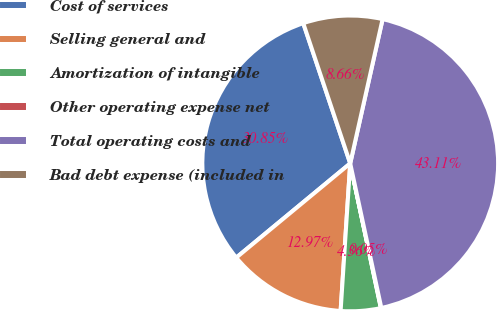Convert chart to OTSL. <chart><loc_0><loc_0><loc_500><loc_500><pie_chart><fcel>Cost of services<fcel>Selling general and<fcel>Amortization of intangible<fcel>Other operating expense net<fcel>Total operating costs and<fcel>Bad debt expense (included in<nl><fcel>30.85%<fcel>12.97%<fcel>4.36%<fcel>0.05%<fcel>43.11%<fcel>8.66%<nl></chart> 